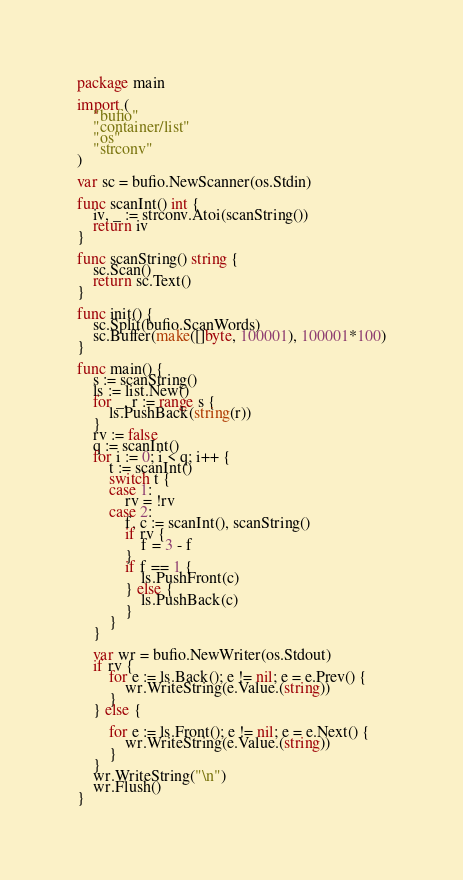<code> <loc_0><loc_0><loc_500><loc_500><_Go_>package main

import (
	"bufio"
	"container/list"
	"os"
	"strconv"
)

var sc = bufio.NewScanner(os.Stdin)

func scanInt() int {
	iv, _ := strconv.Atoi(scanString())
	return iv
}

func scanString() string {
	sc.Scan()
	return sc.Text()
}

func init() {
	sc.Split(bufio.ScanWords)
	sc.Buffer(make([]byte, 100001), 100001*100)
}

func main() {
	s := scanString()
	ls := list.New()
	for _, r := range s {
		ls.PushBack(string(r))
	}
	rv := false
	q := scanInt()
	for i := 0; i < q; i++ {
		t := scanInt()
		switch t {
		case 1:
			rv = !rv
		case 2:
			f, c := scanInt(), scanString()
			if rv {
				f = 3 - f
			}
			if f == 1 {
				ls.PushFront(c)
			} else {
				ls.PushBack(c)
			}
		}
	}

	var wr = bufio.NewWriter(os.Stdout)
	if rv {
		for e := ls.Back(); e != nil; e = e.Prev() {
			wr.WriteString(e.Value.(string))
		}
	} else {

		for e := ls.Front(); e != nil; e = e.Next() {
			wr.WriteString(e.Value.(string))
		}
	}
	wr.WriteString("\n")
	wr.Flush()
}
</code> 